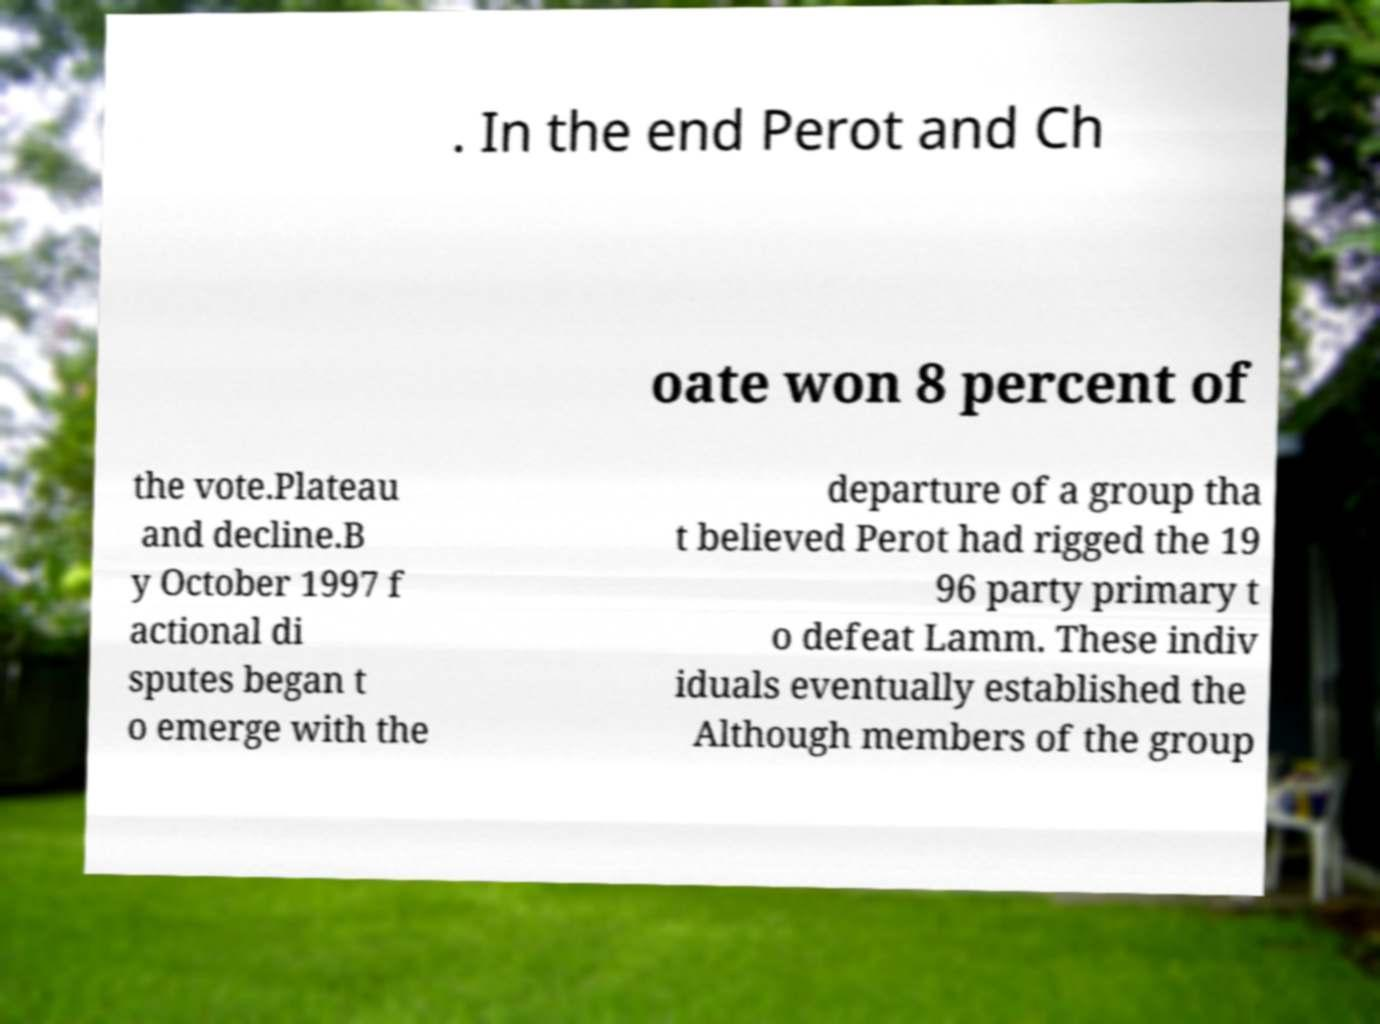I need the written content from this picture converted into text. Can you do that? . In the end Perot and Ch oate won 8 percent of the vote.Plateau and decline.B y October 1997 f actional di sputes began t o emerge with the departure of a group tha t believed Perot had rigged the 19 96 party primary t o defeat Lamm. These indiv iduals eventually established the Although members of the group 